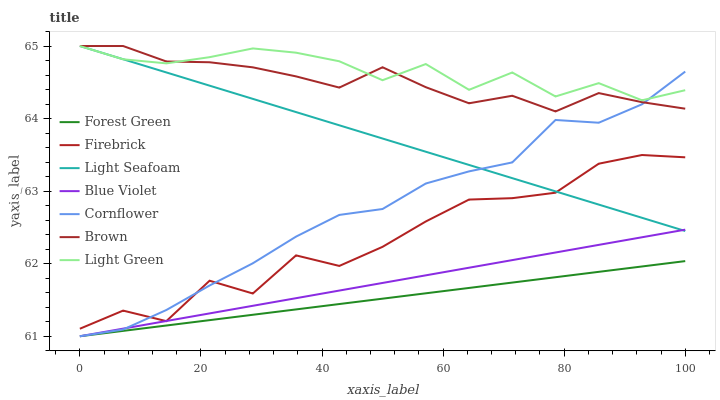Does Forest Green have the minimum area under the curve?
Answer yes or no. Yes. Does Light Green have the maximum area under the curve?
Answer yes or no. Yes. Does Brown have the minimum area under the curve?
Answer yes or no. No. Does Brown have the maximum area under the curve?
Answer yes or no. No. Is Blue Violet the smoothest?
Answer yes or no. Yes. Is Firebrick the roughest?
Answer yes or no. Yes. Is Brown the smoothest?
Answer yes or no. No. Is Brown the roughest?
Answer yes or no. No. Does Cornflower have the lowest value?
Answer yes or no. Yes. Does Brown have the lowest value?
Answer yes or no. No. Does Light Seafoam have the highest value?
Answer yes or no. Yes. Does Firebrick have the highest value?
Answer yes or no. No. Is Blue Violet less than Light Green?
Answer yes or no. Yes. Is Light Green greater than Firebrick?
Answer yes or no. Yes. Does Light Seafoam intersect Blue Violet?
Answer yes or no. Yes. Is Light Seafoam less than Blue Violet?
Answer yes or no. No. Is Light Seafoam greater than Blue Violet?
Answer yes or no. No. Does Blue Violet intersect Light Green?
Answer yes or no. No. 